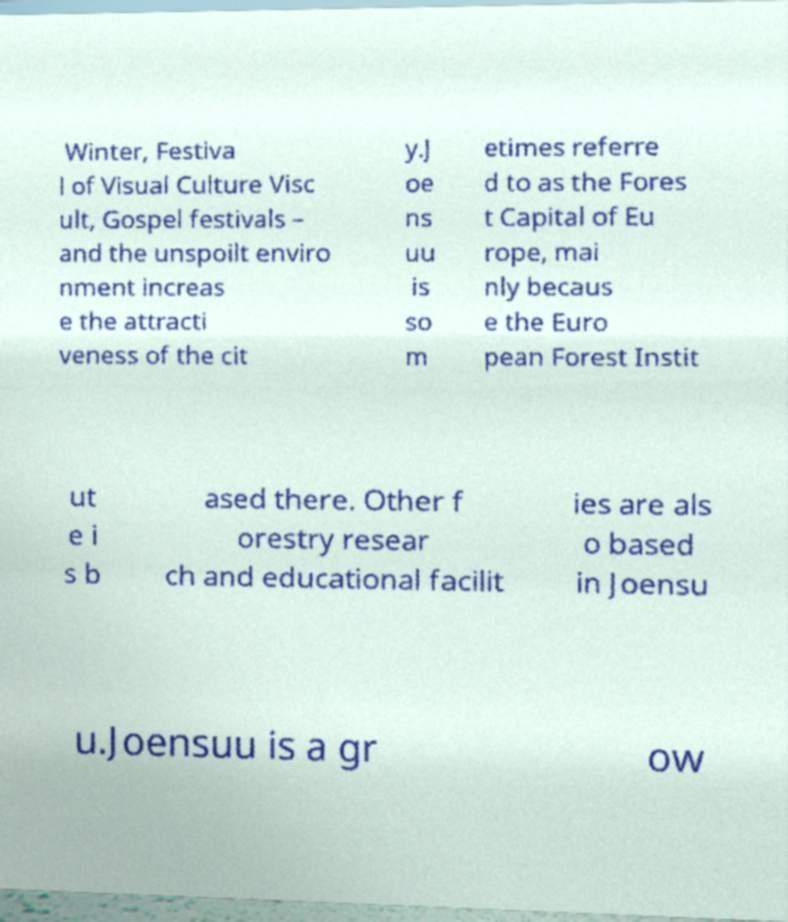Can you read and provide the text displayed in the image?This photo seems to have some interesting text. Can you extract and type it out for me? Winter, Festiva l of Visual Culture Visc ult, Gospel festivals – and the unspoilt enviro nment increas e the attracti veness of the cit y.J oe ns uu is so m etimes referre d to as the Fores t Capital of Eu rope, mai nly becaus e the Euro pean Forest Instit ut e i s b ased there. Other f orestry resear ch and educational facilit ies are als o based in Joensu u.Joensuu is a gr ow 